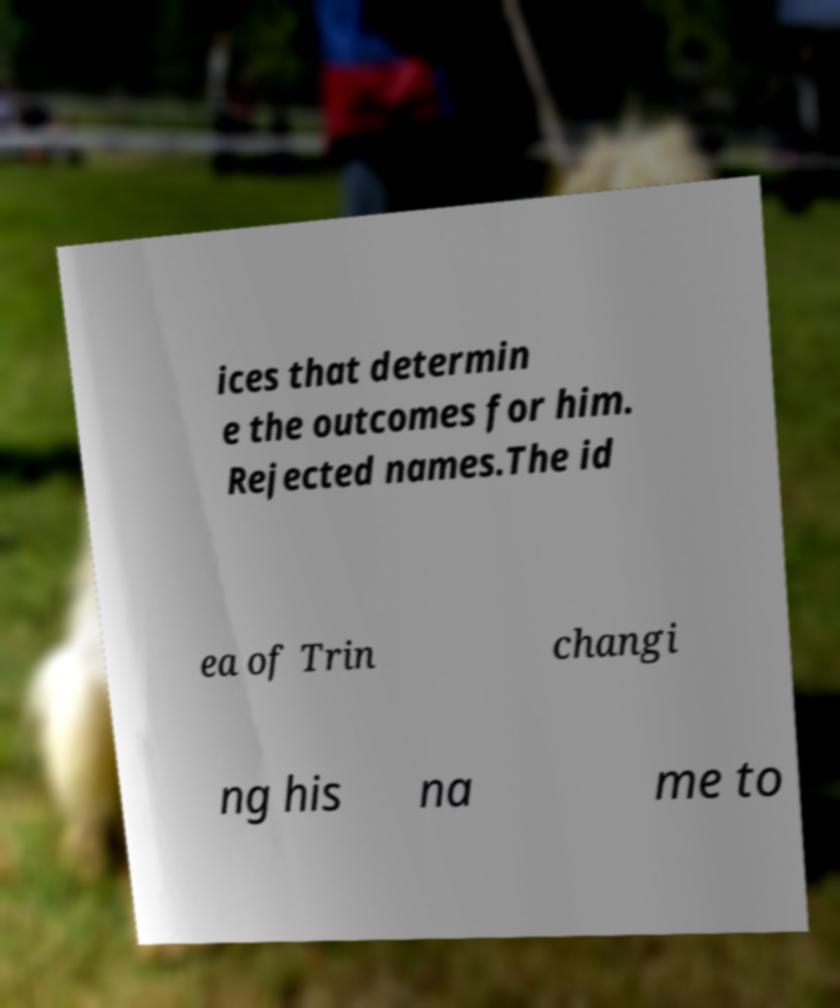Can you accurately transcribe the text from the provided image for me? ices that determin e the outcomes for him. Rejected names.The id ea of Trin changi ng his na me to 